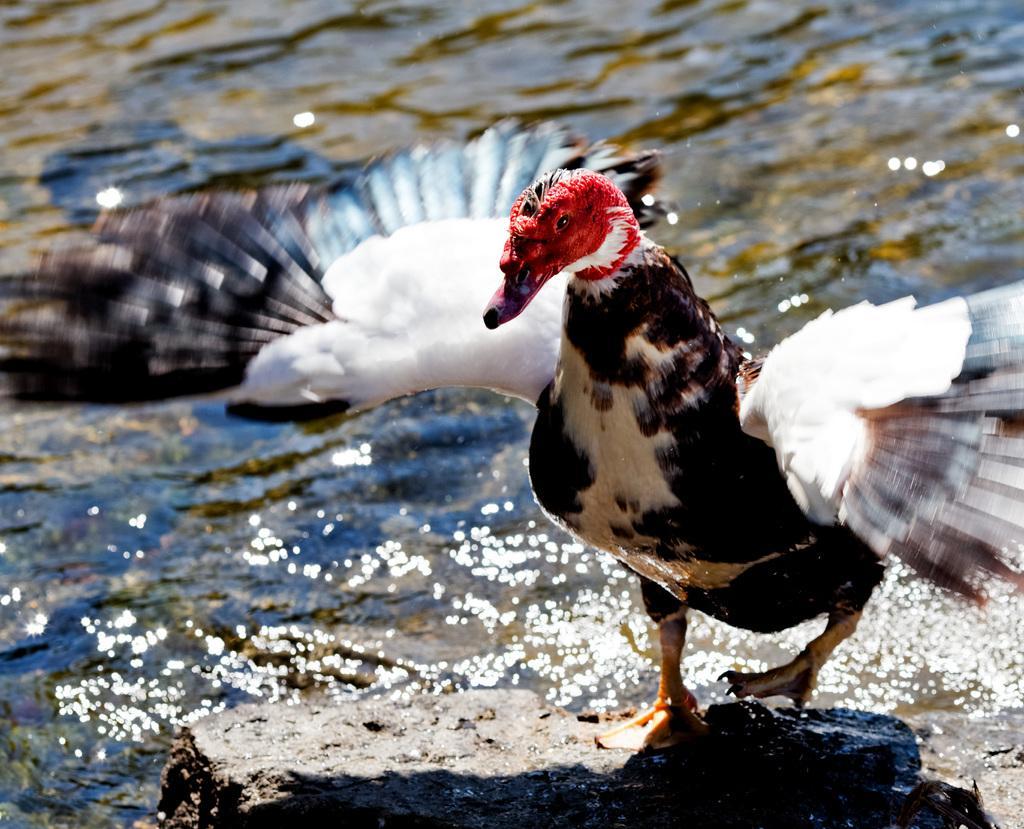How would you summarize this image in a sentence or two? In this image I can see a duck standing on the stone. In the background, I can see the water. 